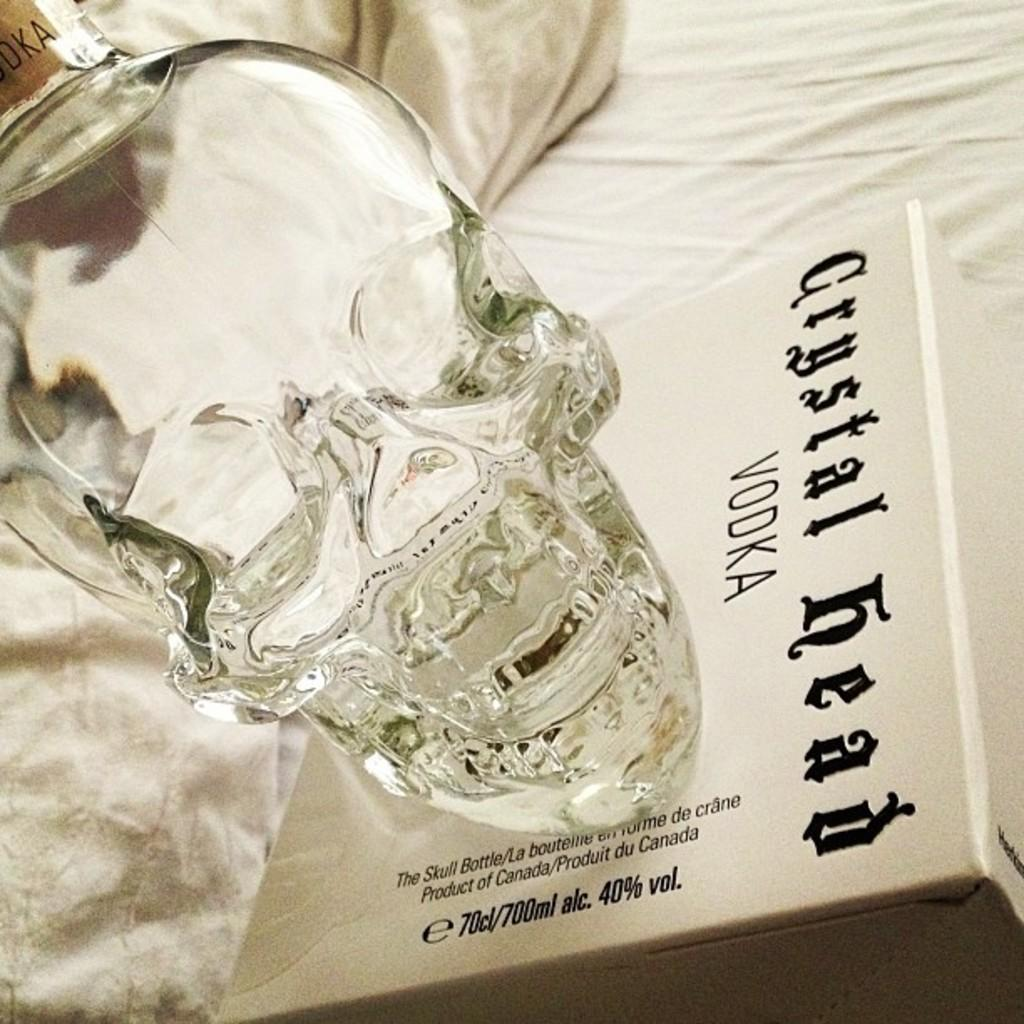<image>
Render a clear and concise summary of the photo. a Chrystal vodka SKULL HEAD with it's box. 